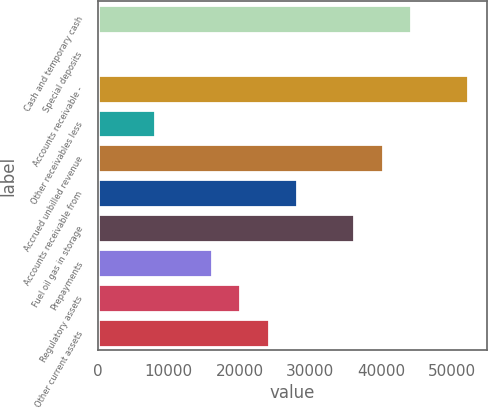Convert chart. <chart><loc_0><loc_0><loc_500><loc_500><bar_chart><fcel>Cash and temporary cash<fcel>Special deposits<fcel>Accounts receivable -<fcel>Other receivables less<fcel>Accrued unbilled revenue<fcel>Accounts receivable from<fcel>Fuel oil gas in storage<fcel>Prepayments<fcel>Regulatory assets<fcel>Other current assets<nl><fcel>44252.8<fcel>2<fcel>52298.4<fcel>8047.6<fcel>40230<fcel>28161.6<fcel>36207.2<fcel>16093.2<fcel>20116<fcel>24138.8<nl></chart> 